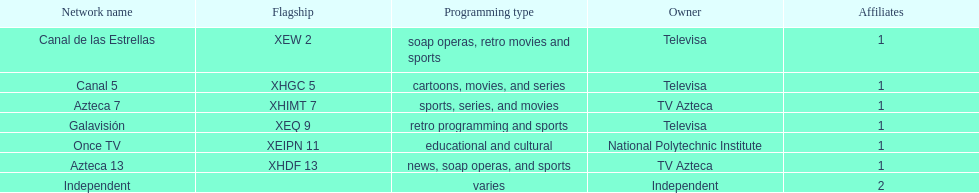How many networks does tv azteca own? 2. 